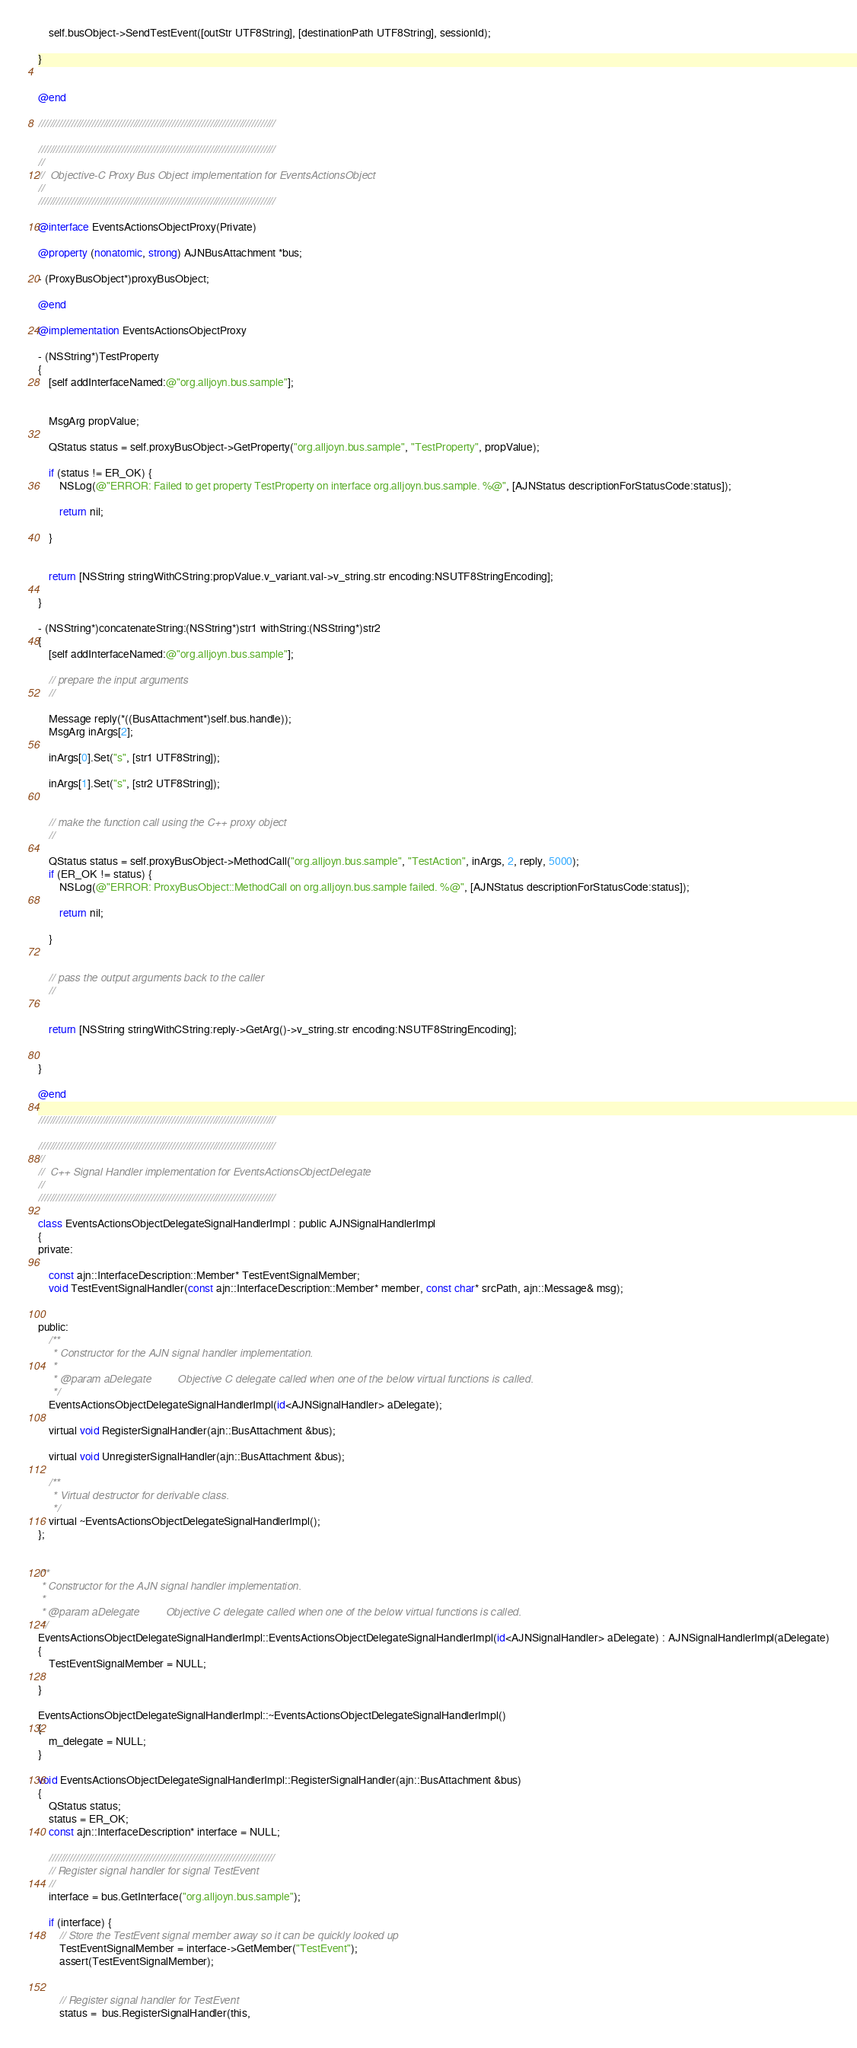<code> <loc_0><loc_0><loc_500><loc_500><_ObjectiveC_>
    self.busObject->SendTestEvent([outStr UTF8String], [destinationPath UTF8String], sessionId);

}


@end

////////////////////////////////////////////////////////////////////////////////

////////////////////////////////////////////////////////////////////////////////
//
//  Objective-C Proxy Bus Object implementation for EventsActionsObject
//
////////////////////////////////////////////////////////////////////////////////

@interface EventsActionsObjectProxy(Private)

@property (nonatomic, strong) AJNBusAttachment *bus;

- (ProxyBusObject*)proxyBusObject;

@end

@implementation EventsActionsObjectProxy

- (NSString*)TestProperty
{
    [self addInterfaceNamed:@"org.alljoyn.bus.sample"];


    MsgArg propValue;

    QStatus status = self.proxyBusObject->GetProperty("org.alljoyn.bus.sample", "TestProperty", propValue);

    if (status != ER_OK) {
        NSLog(@"ERROR: Failed to get property TestProperty on interface org.alljoyn.bus.sample. %@", [AJNStatus descriptionForStatusCode:status]);

        return nil;

    }


    return [NSString stringWithCString:propValue.v_variant.val->v_string.str encoding:NSUTF8StringEncoding];

}

- (NSString*)concatenateString:(NSString*)str1 withString:(NSString*)str2
{
    [self addInterfaceNamed:@"org.alljoyn.bus.sample"];

    // prepare the input arguments
    //

    Message reply(*((BusAttachment*)self.bus.handle));
    MsgArg inArgs[2];

    inArgs[0].Set("s", [str1 UTF8String]);

    inArgs[1].Set("s", [str2 UTF8String]);


    // make the function call using the C++ proxy object
    //

    QStatus status = self.proxyBusObject->MethodCall("org.alljoyn.bus.sample", "TestAction", inArgs, 2, reply, 5000);
    if (ER_OK != status) {
        NSLog(@"ERROR: ProxyBusObject::MethodCall on org.alljoyn.bus.sample failed. %@", [AJNStatus descriptionForStatusCode:status]);

        return nil;

    }


    // pass the output arguments back to the caller
    //


    return [NSString stringWithCString:reply->GetArg()->v_string.str encoding:NSUTF8StringEncoding];


}

@end

////////////////////////////////////////////////////////////////////////////////

////////////////////////////////////////////////////////////////////////////////
//
//  C++ Signal Handler implementation for EventsActionsObjectDelegate
//
////////////////////////////////////////////////////////////////////////////////

class EventsActionsObjectDelegateSignalHandlerImpl : public AJNSignalHandlerImpl
{
private:

    const ajn::InterfaceDescription::Member* TestEventSignalMember;
    void TestEventSignalHandler(const ajn::InterfaceDescription::Member* member, const char* srcPath, ajn::Message& msg);


public:
    /**
     * Constructor for the AJN signal handler implementation.
     *
     * @param aDelegate         Objective C delegate called when one of the below virtual functions is called.
     */
    EventsActionsObjectDelegateSignalHandlerImpl(id<AJNSignalHandler> aDelegate);

    virtual void RegisterSignalHandler(ajn::BusAttachment &bus);

    virtual void UnregisterSignalHandler(ajn::BusAttachment &bus);

    /**
     * Virtual destructor for derivable class.
     */
    virtual ~EventsActionsObjectDelegateSignalHandlerImpl();
};


/**
 * Constructor for the AJN signal handler implementation.
 *
 * @param aDelegate         Objective C delegate called when one of the below virtual functions is called.
 */
EventsActionsObjectDelegateSignalHandlerImpl::EventsActionsObjectDelegateSignalHandlerImpl(id<AJNSignalHandler> aDelegate) : AJNSignalHandlerImpl(aDelegate)
{
	TestEventSignalMember = NULL;

}

EventsActionsObjectDelegateSignalHandlerImpl::~EventsActionsObjectDelegateSignalHandlerImpl()
{
    m_delegate = NULL;
}

void EventsActionsObjectDelegateSignalHandlerImpl::RegisterSignalHandler(ajn::BusAttachment &bus)
{
    QStatus status;
    status = ER_OK;
    const ajn::InterfaceDescription* interface = NULL;

    ////////////////////////////////////////////////////////////////////////////
    // Register signal handler for signal TestEvent
    //
    interface = bus.GetInterface("org.alljoyn.bus.sample");

    if (interface) {
        // Store the TestEvent signal member away so it can be quickly looked up
        TestEventSignalMember = interface->GetMember("TestEvent");
        assert(TestEventSignalMember);


        // Register signal handler for TestEvent
        status =  bus.RegisterSignalHandler(this,</code> 